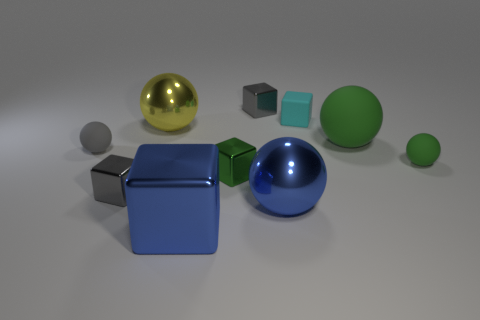Subtract 1 spheres. How many spheres are left? 4 Subtract all yellow balls. Subtract all gray cylinders. How many balls are left? 4 Add 1 gray spheres. How many gray spheres are left? 2 Add 9 tiny shiny balls. How many tiny shiny balls exist? 9 Subtract 0 yellow cylinders. How many objects are left? 10 Subtract all large blue metallic objects. Subtract all tiny objects. How many objects are left? 2 